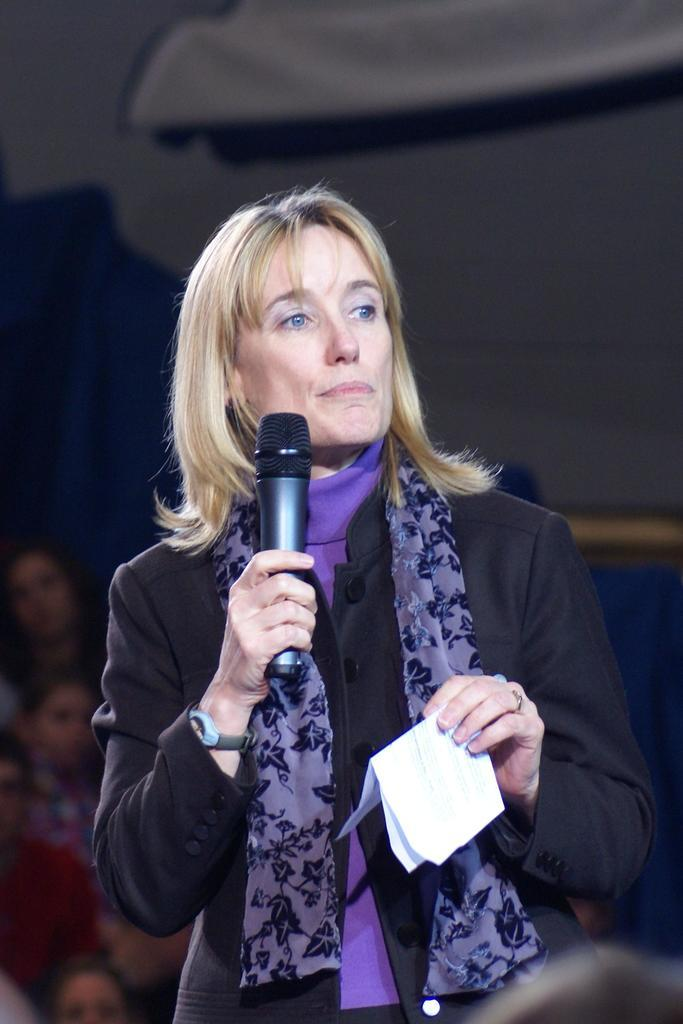Who is the main subject in the image? There is a woman in the center of the image. What is the woman holding in her hands? The woman is holding a microphone and a paper. What can be seen in the background of the image? There are people sitting in the background of the image, and there is a wall. What type of glass is the woman using to enhance her memory in the image? There is no glass present in the image, and the woman is not using any object to enhance her memory. 